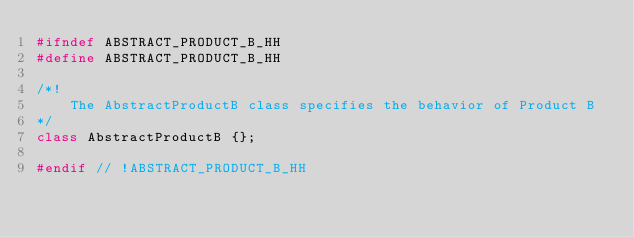<code> <loc_0><loc_0><loc_500><loc_500><_C++_>#ifndef ABSTRACT_PRODUCT_B_HH
#define ABSTRACT_PRODUCT_B_HH

/*!
    The AbstractProductB class specifies the behavior of Product B
*/
class AbstractProductB {};

#endif // !ABSTRACT_PRODUCT_B_HH
</code> 